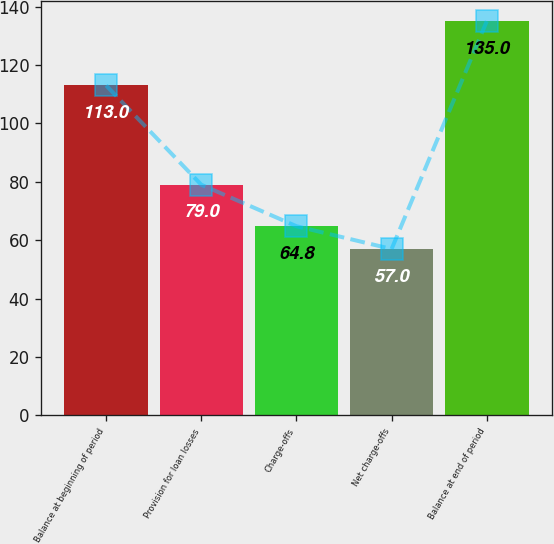<chart> <loc_0><loc_0><loc_500><loc_500><bar_chart><fcel>Balance at beginning of period<fcel>Provision for loan losses<fcel>Charge-offs<fcel>Net charge-offs<fcel>Balance at end of period<nl><fcel>113<fcel>79<fcel>64.8<fcel>57<fcel>135<nl></chart> 